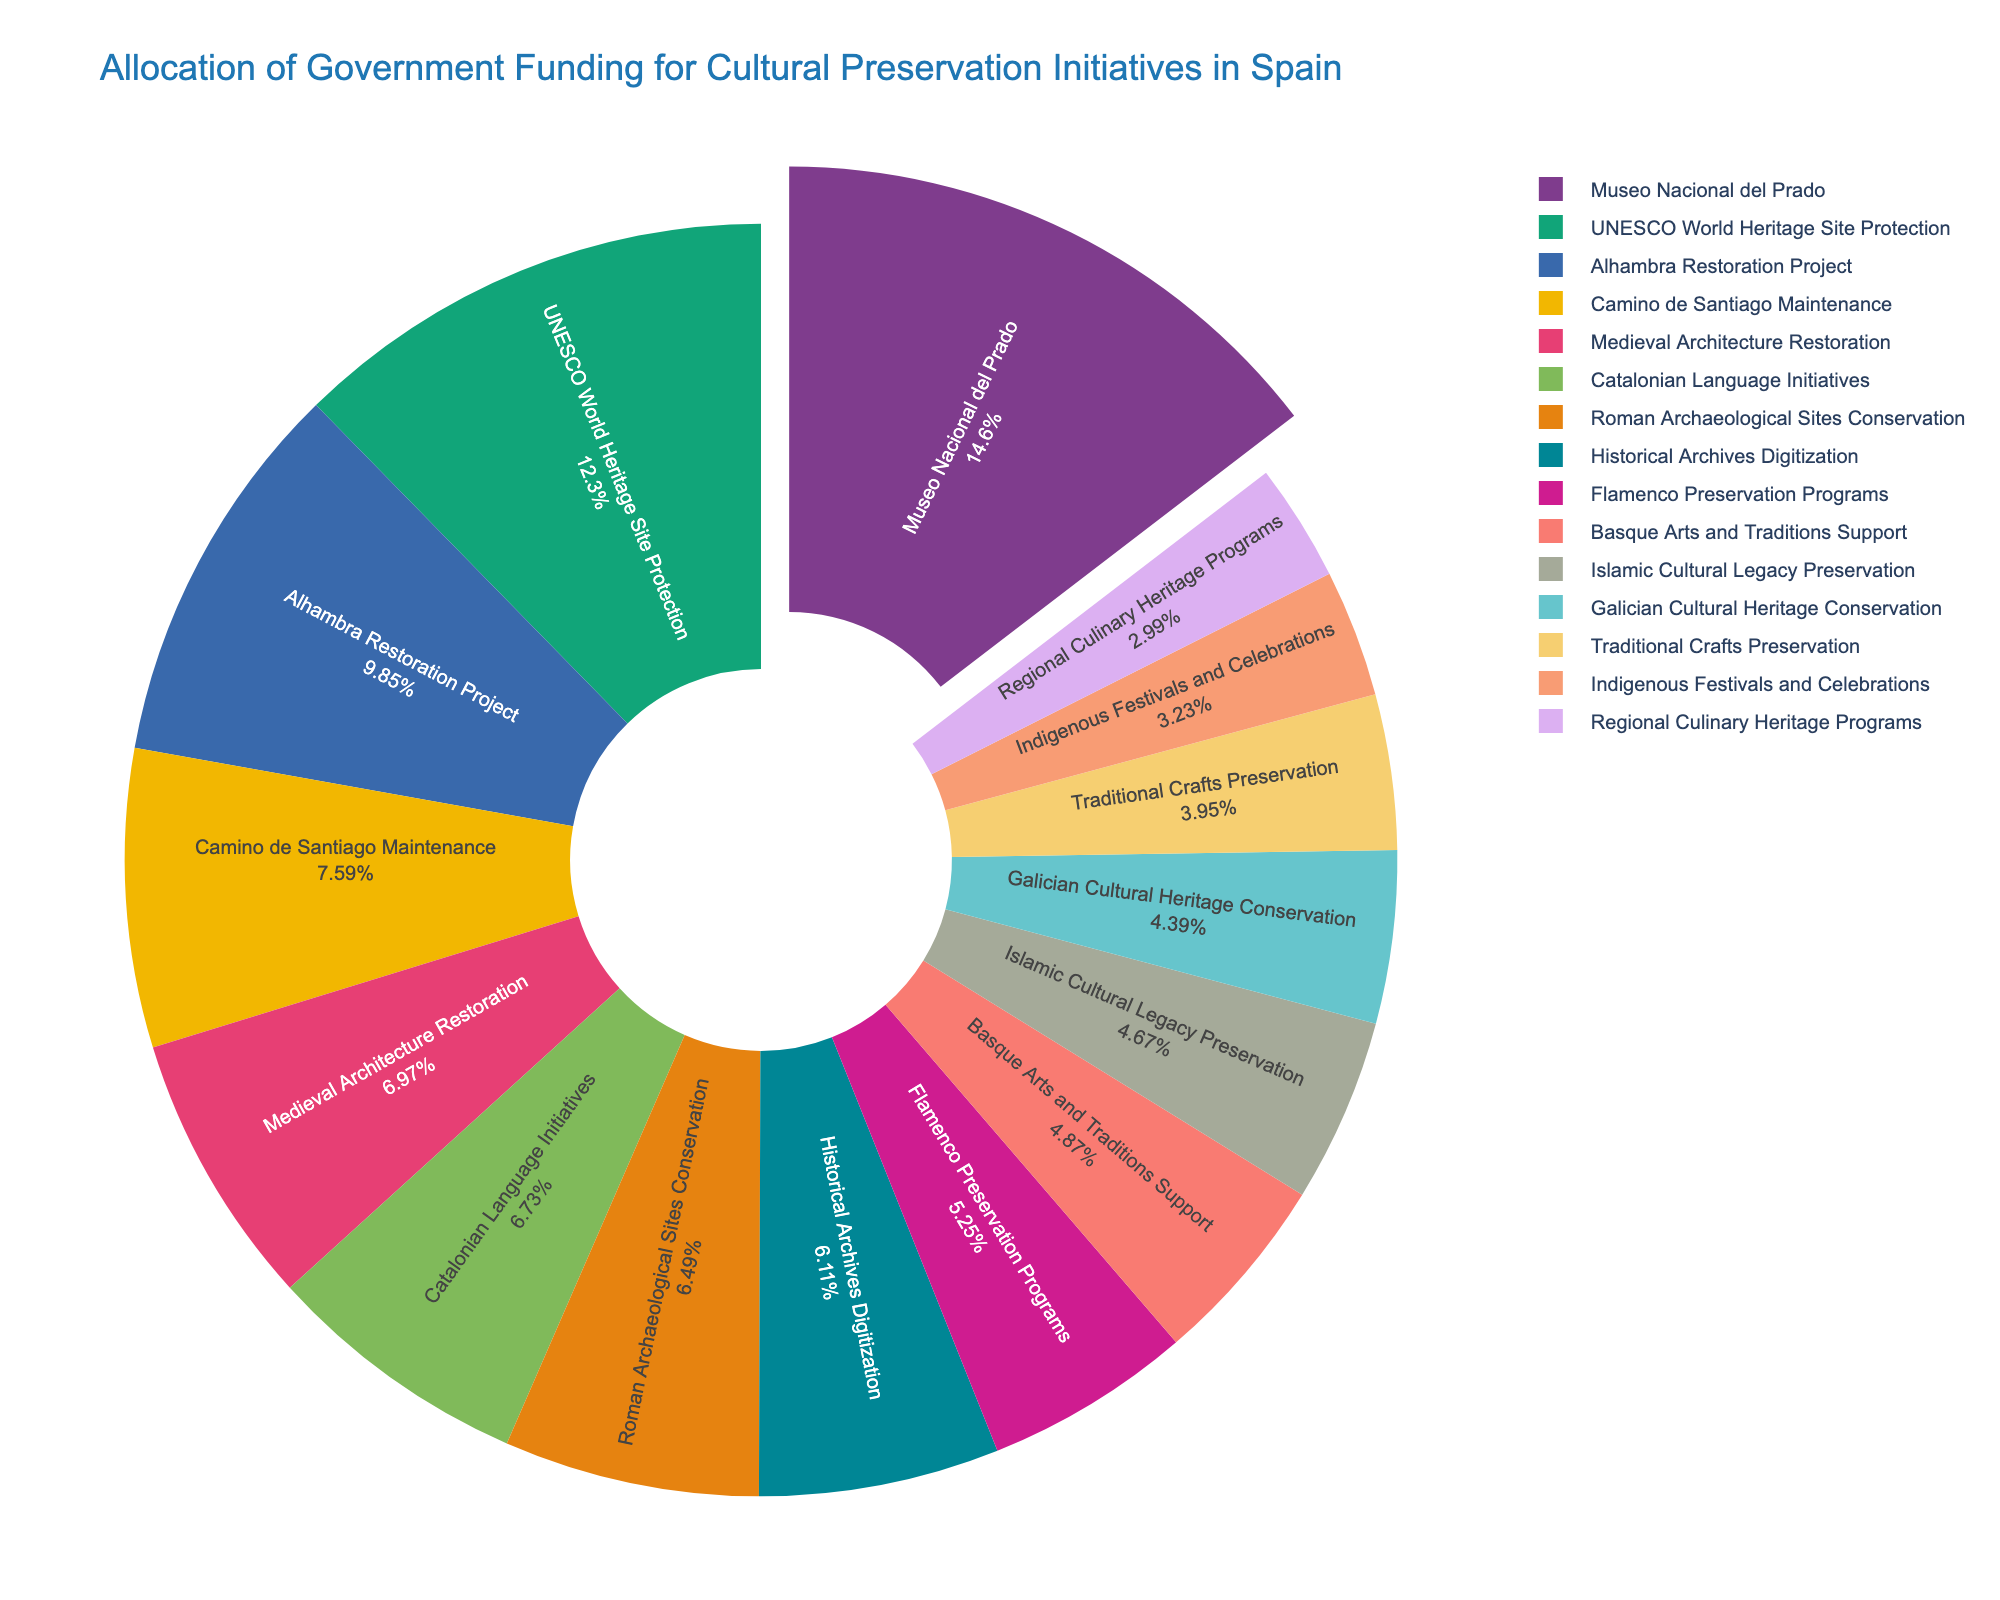What's the largest funding category? The largest funding category is identified by the biggest slice of the pie chart. It is Museo Nacional del Prado.
Answer: Museo Nacional del Prado Which category has the least funding? The smallest slice of the pie chart represents the category with the least funding. It is Regional Culinary Heritage Programs.
Answer: Regional Culinary Heritage Programs How much more funding does the Museo Nacional del Prado receive than the Indigenous Festivals and Celebrations? Identify the funding amounts for both categories: Museo Nacional del Prado (42.5 million Euros) and Indigenous Festivals and Celebrations (9.4 million Euros). Calculate the difference: 42.5 - 9.4 = 33.1
Answer: 33.1 million Euros What is the combined funding for Catalonian Language Initiatives and Galician Cultural Heritage Conservation? Identify the funding amounts for both categories: Catalonian Language Initiatives (19.6 million Euros) and Galician Cultural Heritage Conservation (12.8 million Euros). Sum them up: 19.6 + 12.8 = 32.4
Answer: 32.4 million Euros Which categories receive more funding than the Alhambra Restoration Project? Identify the funding amount for the Alhambra Restoration Project (28.7 million Euros) and compare it with others: Museo Nacional del Prado (42.5 million Euros), UNESCO World Heritage Site Protection (35.9 million Euros). Both receive more.
Answer: Museo Nacional del Prado, UNESCO World Heritage Site Protection What percentage of the total funding is allocated to UNESCO World Heritage Site Protection? The total funding is the sum of all categories. Identify the UNESCO World Heritage Site Protection's funding (35.9 million Euros). Calculate its percentage of the total: (35.9 / total funding) * 100. Total funding is 281.1 million Euros, so (35.9 / 281.1) * 100 ≈ 12.8%
Answer: 12.8% How does the funding for Flamenco Preservation Programs compare to that of Traditional Crafts Preservation? Identify the funding amounts for both categories: Flamenco Preservation Programs (15.3 million Euros) and Traditional Crafts Preservation (11.5 million Euros). Flamenco Preservation Programs receive more funding.
Answer: Flamenco Preservation Programs receive more funding What's the total funding allocated to initiatives related to architectural restoration? Identify and sum the funding for categories related to architectural restoration: Alhambra Restoration Project (28.7 million Euros), Camino de Santiago Maintenance (22.1 million Euros), Medieval Architecture Restoration (20.3 million Euros), Roman Archaeological Sites Conservation (18.9 million Euros). Total: 28.7 + 22.1 + 20.3 + 18.9 = 90
Answer: 90 million Euros Which category receives slightly more funding, Islamic Cultural Legacy Preservation or Basque Arts and Traditions Support? Compare the funding amounts: Islamic Cultural Legacy Preservation (13.6 million Euros) and Basque Arts and Traditions Support (14.2 million Euros). Basque Arts and Traditions Support receives slightly more.
Answer: Basque Arts and Traditions Support What is the combined percentage of funding for Indigenous Festivals and Celebrations and Regional Culinary Heritage Programs? Calculate the individual percentages: Indigenous Festivals and Celebrations (9.4 million Euros) and Regional Culinary Heritage Programs (8.7 million Euros) of the total funding (281.1 million Euros). (9.4 / 281.1) * 100 ≈ 3.34% and (8.7 / 281.1) * 100 ≈ 3.10%. Sum: 3.34% + 3.10% ≈ 6.44%
Answer: 6.44% 